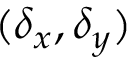<formula> <loc_0><loc_0><loc_500><loc_500>( \delta _ { x } , \delta _ { y } )</formula> 